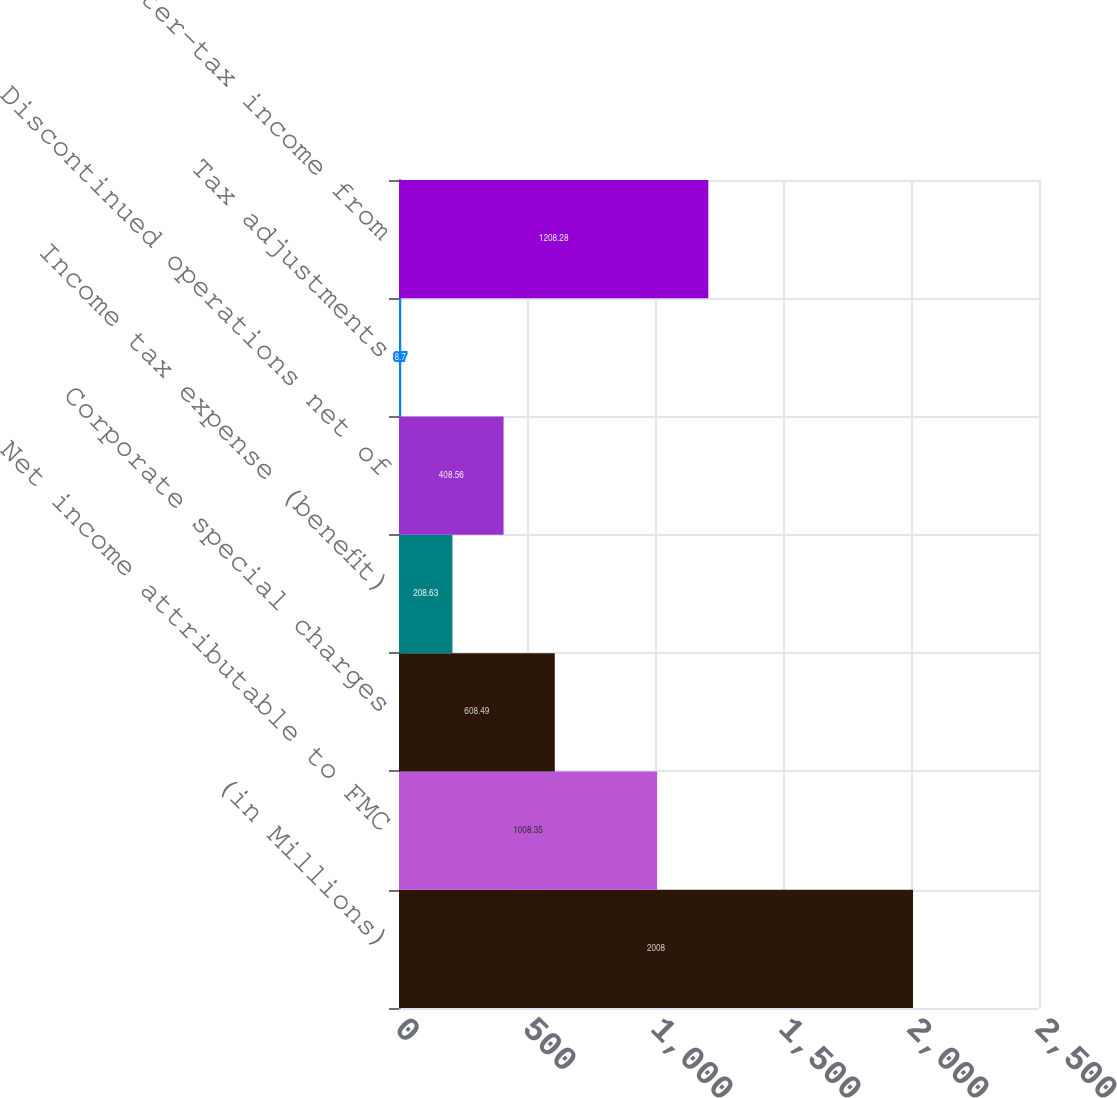Convert chart to OTSL. <chart><loc_0><loc_0><loc_500><loc_500><bar_chart><fcel>(in Millions)<fcel>Net income attributable to FMC<fcel>Corporate special charges<fcel>Income tax expense (benefit)<fcel>Discontinued operations net of<fcel>Tax adjustments<fcel>after-tax income from<nl><fcel>2008<fcel>1008.35<fcel>608.49<fcel>208.63<fcel>408.56<fcel>8.7<fcel>1208.28<nl></chart> 